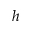Convert formula to latex. <formula><loc_0><loc_0><loc_500><loc_500>h</formula> 